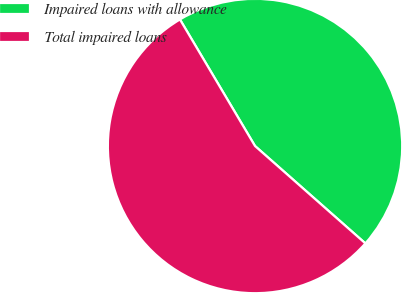Convert chart to OTSL. <chart><loc_0><loc_0><loc_500><loc_500><pie_chart><fcel>Impaired loans with allowance<fcel>Total impaired loans<nl><fcel>45.03%<fcel>54.97%<nl></chart> 